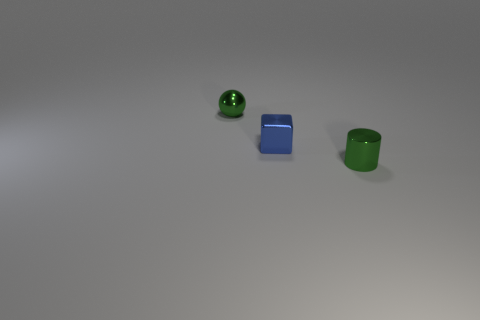Add 1 small things. How many objects exist? 4 Subtract 0 purple cubes. How many objects are left? 3 Subtract all cubes. How many objects are left? 2 Subtract all small blue metal cubes. Subtract all green spheres. How many objects are left? 1 Add 3 tiny green metal spheres. How many tiny green metal spheres are left? 4 Add 3 tiny shiny things. How many tiny shiny things exist? 6 